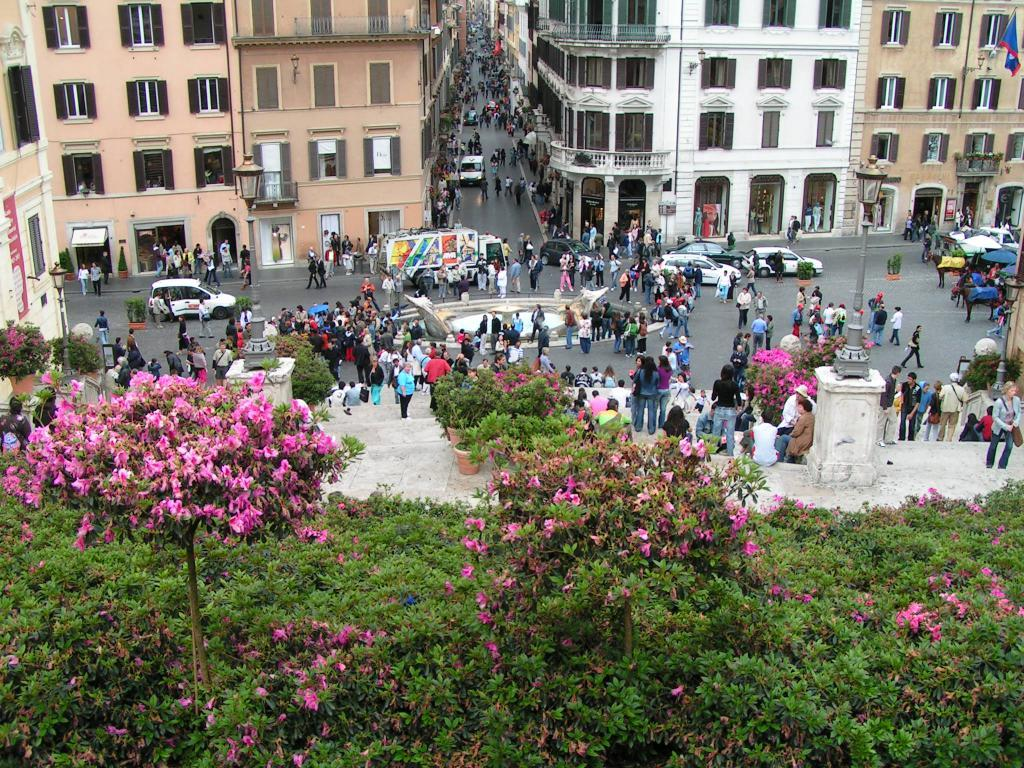What is the main subject of the image? The main subject of the image is a crowd. What else can be seen in the image besides the crowd? There are vehicles on the road, plants with flowers, poles, lights, a flag, boards, and buildings in the background. Can you describe the vehicles in the image? The vehicles on the road are not specified in the facts, so we cannot describe them. What type of plants are present in the image? The plants with flowers are not specified in the facts, so we cannot describe them. What are the poles used for in the image? The purpose of the poles is not specified in the facts, so we cannot determine their use. What is the flag representing in the image? The flag is not specified in the facts, so we cannot determine what it represents. What are the boards used for in the image? The purpose of the boards is not specified in the facts, so we cannot determine their use. What type of buildings can be seen in the background of the image? The buildings in the background are not specified in the facts, so we cannot describe them. What time of day is the jelly being served in the image? There is no mention of jelly or any food being served in the image, so we cannot determine the time of day. 